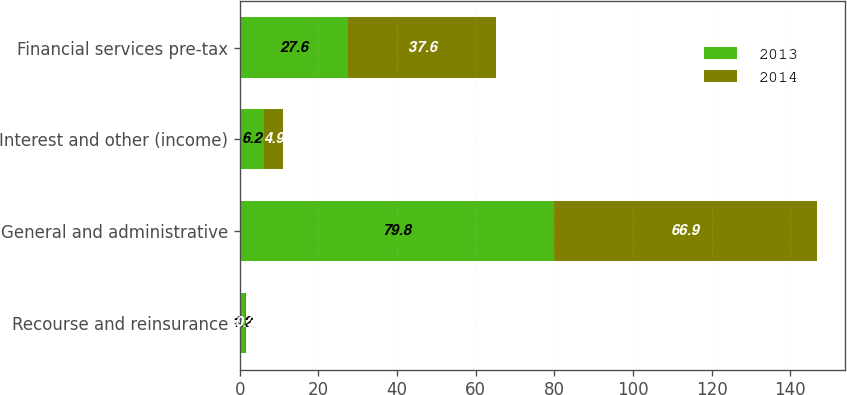Convert chart. <chart><loc_0><loc_0><loc_500><loc_500><stacked_bar_chart><ecel><fcel>Recourse and reinsurance<fcel>General and administrative<fcel>Interest and other (income)<fcel>Financial services pre-tax<nl><fcel>2013<fcel>1.2<fcel>79.8<fcel>6.2<fcel>27.6<nl><fcel>2014<fcel>0.3<fcel>66.9<fcel>4.9<fcel>37.6<nl></chart> 